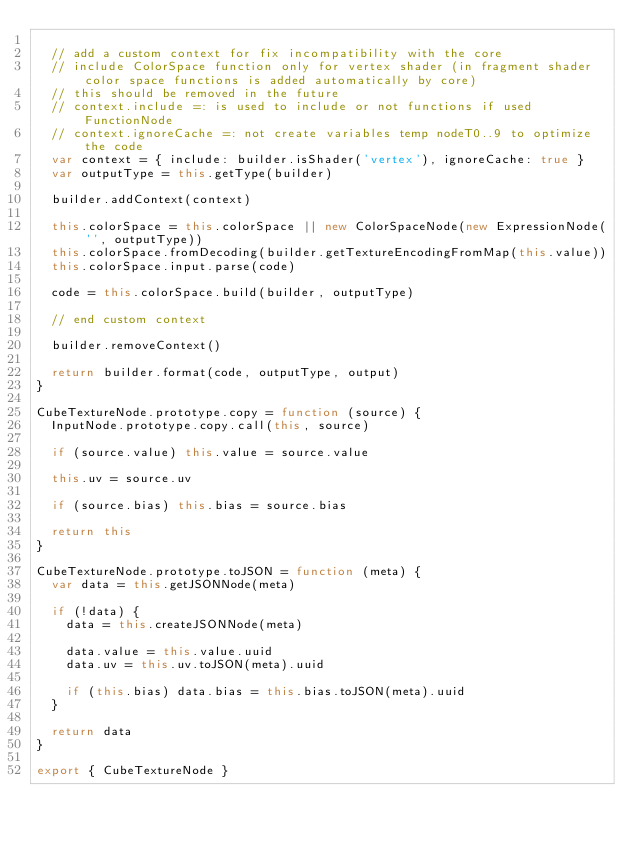<code> <loc_0><loc_0><loc_500><loc_500><_JavaScript_>
  // add a custom context for fix incompatibility with the core
  // include ColorSpace function only for vertex shader (in fragment shader color space functions is added automatically by core)
  // this should be removed in the future
  // context.include =: is used to include or not functions if used FunctionNode
  // context.ignoreCache =: not create variables temp nodeT0..9 to optimize the code
  var context = { include: builder.isShader('vertex'), ignoreCache: true }
  var outputType = this.getType(builder)

  builder.addContext(context)

  this.colorSpace = this.colorSpace || new ColorSpaceNode(new ExpressionNode('', outputType))
  this.colorSpace.fromDecoding(builder.getTextureEncodingFromMap(this.value))
  this.colorSpace.input.parse(code)

  code = this.colorSpace.build(builder, outputType)

  // end custom context

  builder.removeContext()

  return builder.format(code, outputType, output)
}

CubeTextureNode.prototype.copy = function (source) {
  InputNode.prototype.copy.call(this, source)

  if (source.value) this.value = source.value

  this.uv = source.uv

  if (source.bias) this.bias = source.bias

  return this
}

CubeTextureNode.prototype.toJSON = function (meta) {
  var data = this.getJSONNode(meta)

  if (!data) {
    data = this.createJSONNode(meta)

    data.value = this.value.uuid
    data.uv = this.uv.toJSON(meta).uuid

    if (this.bias) data.bias = this.bias.toJSON(meta).uuid
  }

  return data
}

export { CubeTextureNode }
</code> 